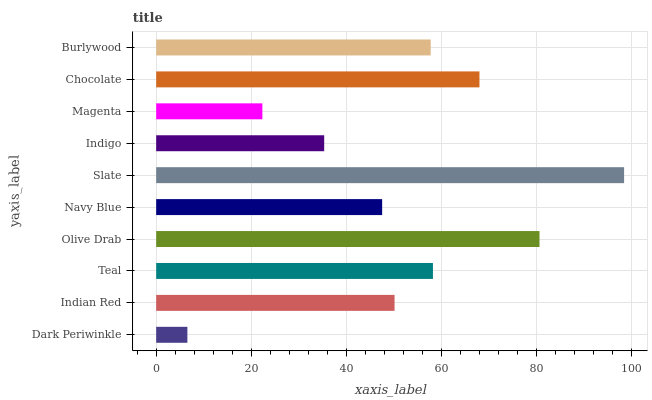Is Dark Periwinkle the minimum?
Answer yes or no. Yes. Is Slate the maximum?
Answer yes or no. Yes. Is Indian Red the minimum?
Answer yes or no. No. Is Indian Red the maximum?
Answer yes or no. No. Is Indian Red greater than Dark Periwinkle?
Answer yes or no. Yes. Is Dark Periwinkle less than Indian Red?
Answer yes or no. Yes. Is Dark Periwinkle greater than Indian Red?
Answer yes or no. No. Is Indian Red less than Dark Periwinkle?
Answer yes or no. No. Is Burlywood the high median?
Answer yes or no. Yes. Is Indian Red the low median?
Answer yes or no. Yes. Is Indian Red the high median?
Answer yes or no. No. Is Magenta the low median?
Answer yes or no. No. 